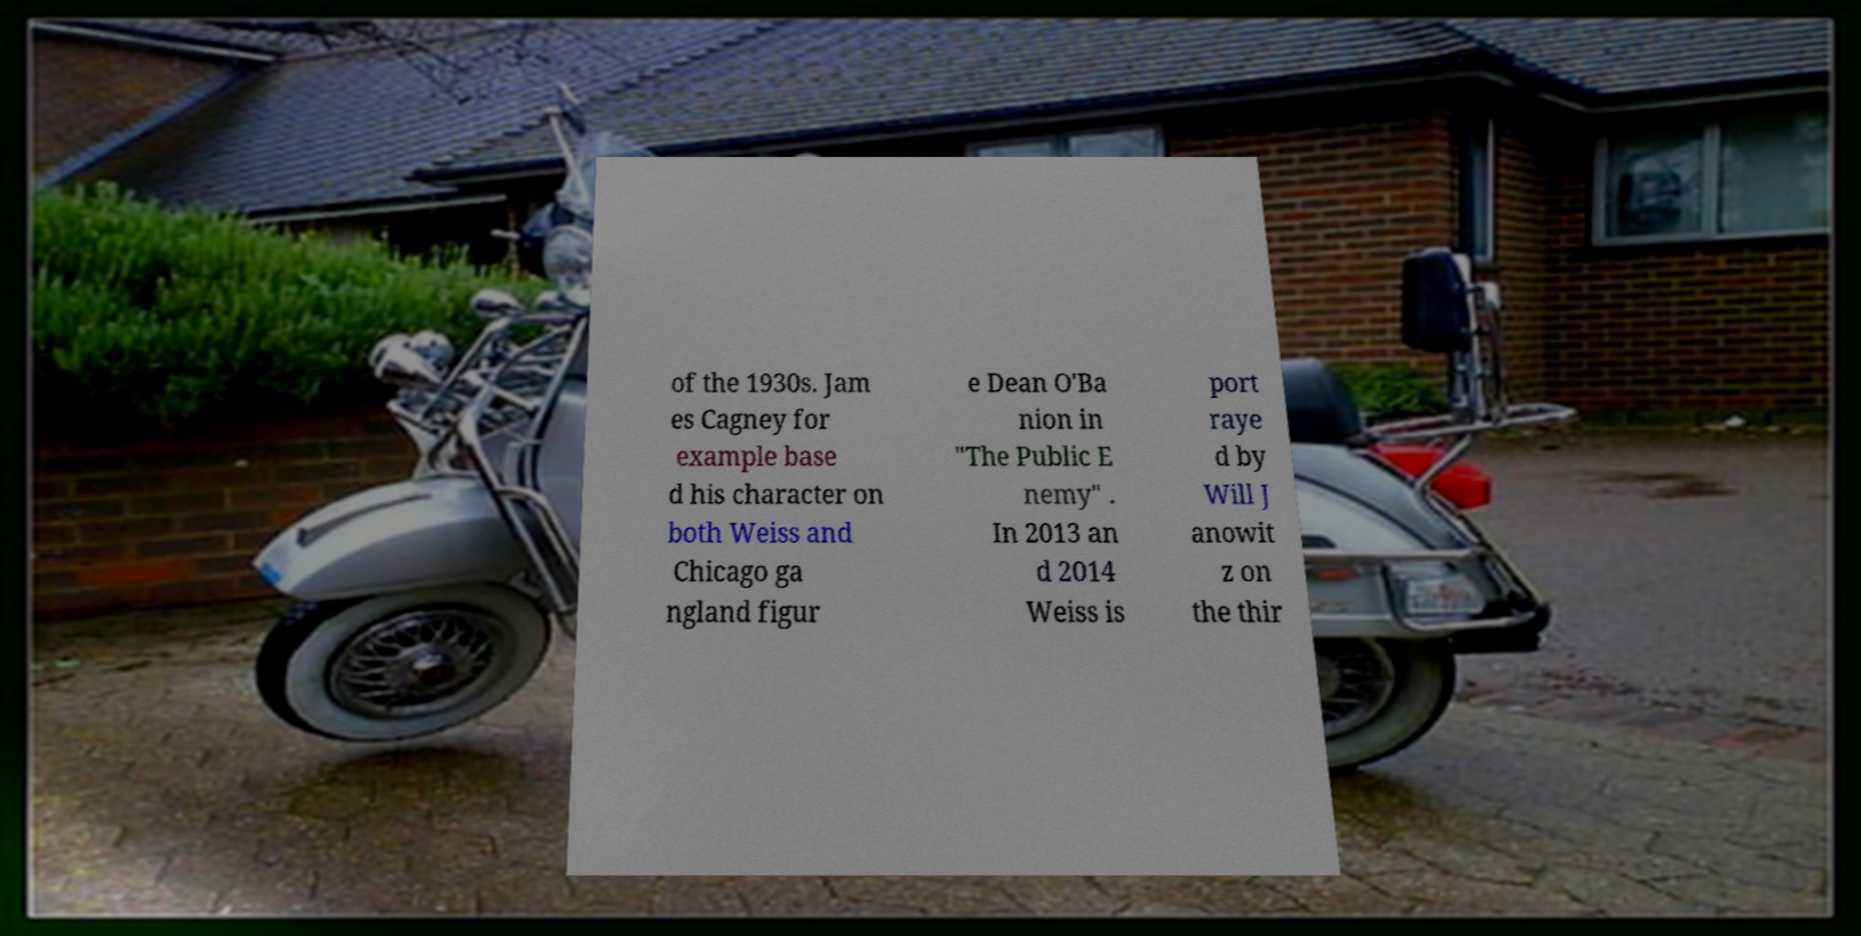Can you accurately transcribe the text from the provided image for me? of the 1930s. Jam es Cagney for example base d his character on both Weiss and Chicago ga ngland figur e Dean O'Ba nion in "The Public E nemy" . In 2013 an d 2014 Weiss is port raye d by Will J anowit z on the thir 